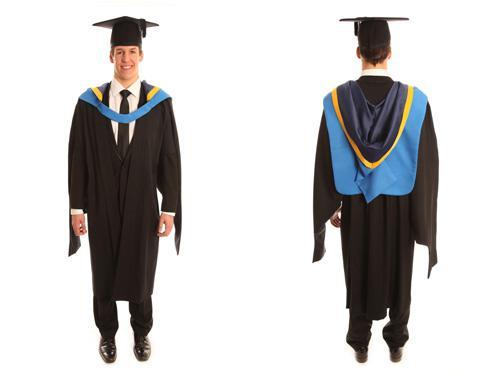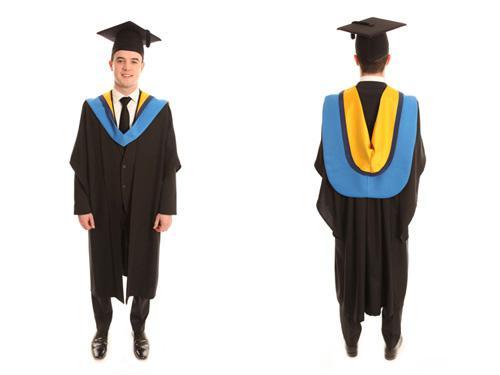The first image is the image on the left, the second image is the image on the right. Assess this claim about the two images: "All graduation gown models are one gender.". Correct or not? Answer yes or no. Yes. The first image is the image on the left, the second image is the image on the right. Examine the images to the left and right. Is the description "At least one image shows only a female graduate." accurate? Answer yes or no. No. 